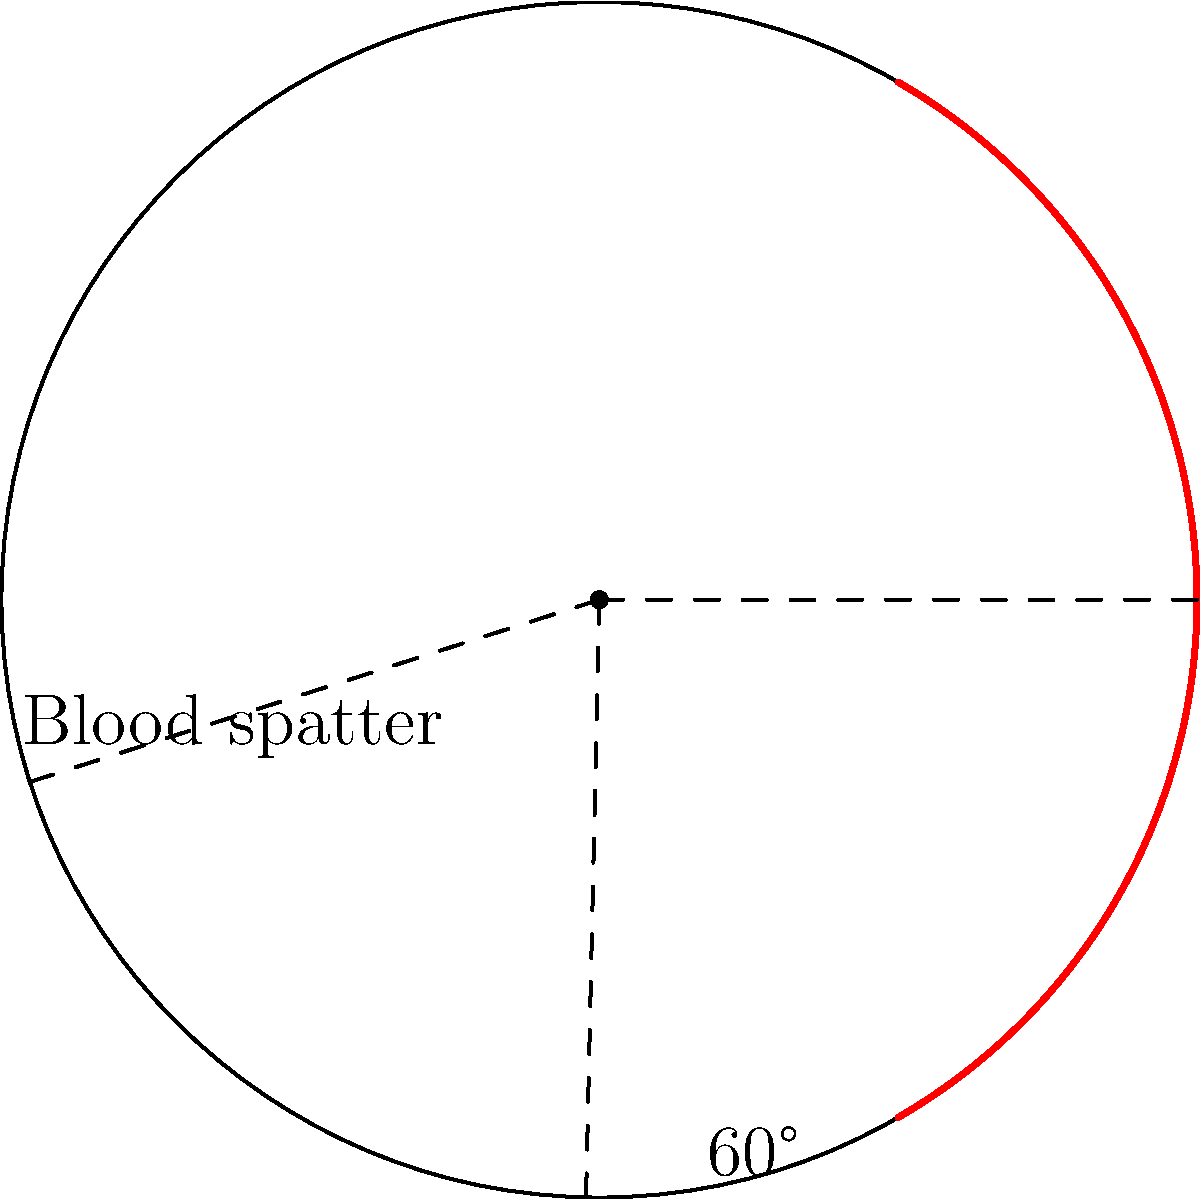In a circular room with a radius of 5 meters, blood spatter from a crime scene is found in two distinct arcs on the wall. The first arc spans from 0° to 60°, and the second arc spans from 300° to 360° in polar coordinates. What is the total angular spread of the blood spatter pattern in degrees? To solve this problem, we need to follow these steps:

1. Identify the angular spans of the two blood spatter arcs:
   - Arc 1: 0° to 60°
   - Arc 2: 300° to 360°

2. Calculate the angular spread of each arc:
   - Arc 1 spread: $60° - 0° = 60°$
   - Arc 2 spread: $360° - 300° = 60°$

3. Sum up the angular spreads of both arcs:
   Total angular spread = Arc 1 spread + Arc 2 spread
   $= 60° + 60° = 120°$

The total angular spread of the blood spatter pattern is 120°.

This analysis is crucial for forensic scientists to determine the origin of the blood spatter and potentially reconstruct the crime scene. The angular spread can provide information about the location and nature of the impact that caused the blood spatter.
Answer: 120° 